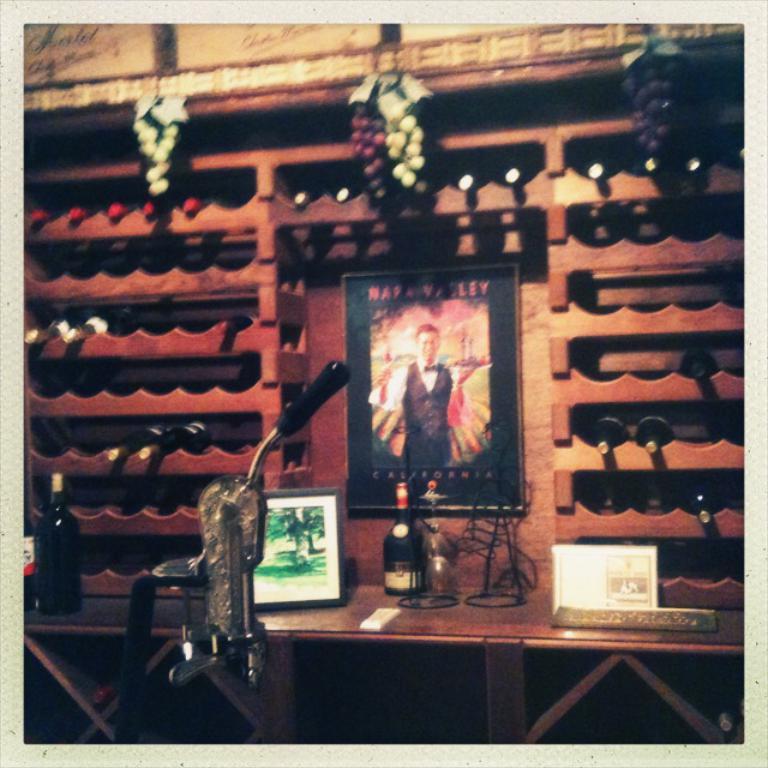What us state is written on the bottom of the poster?
Make the answer very short. California. 